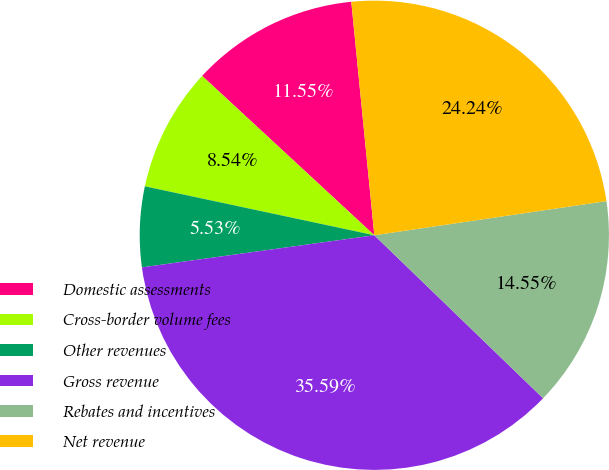<chart> <loc_0><loc_0><loc_500><loc_500><pie_chart><fcel>Domestic assessments<fcel>Cross-border volume fees<fcel>Other revenues<fcel>Gross revenue<fcel>Rebates and incentives<fcel>Net revenue<nl><fcel>11.55%<fcel>8.54%<fcel>5.53%<fcel>35.59%<fcel>14.55%<fcel>24.24%<nl></chart> 